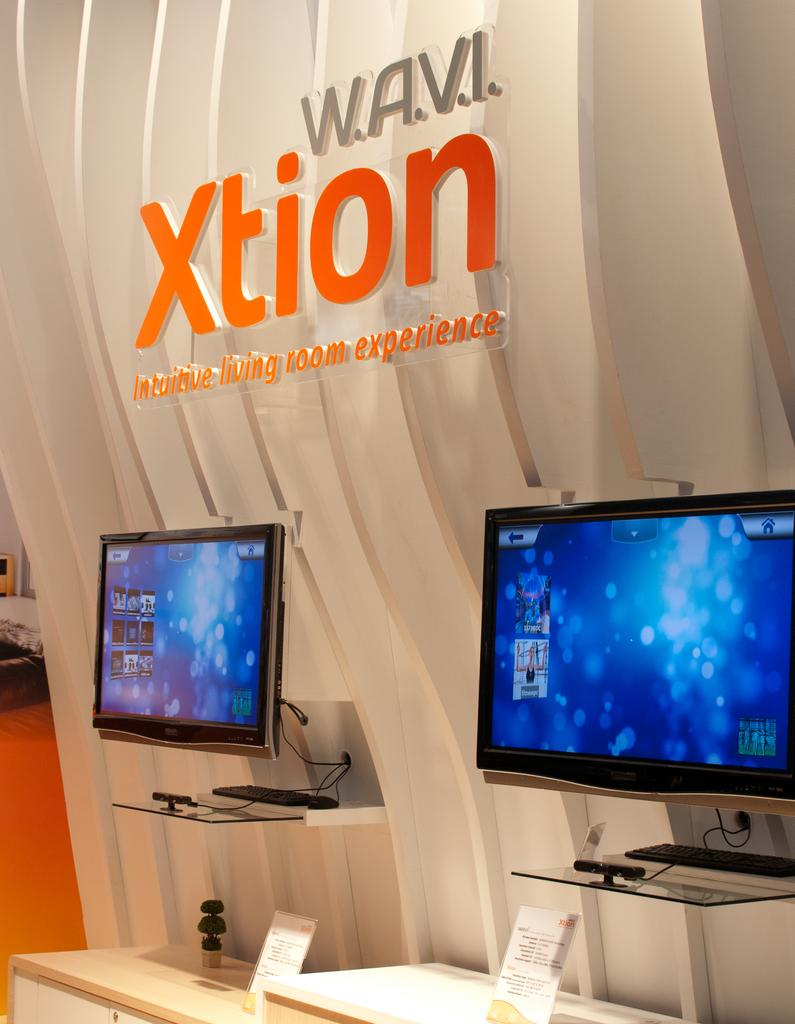<image>
Relay a brief, clear account of the picture shown. Computer monitors are on display for a Xtion experience booth. 